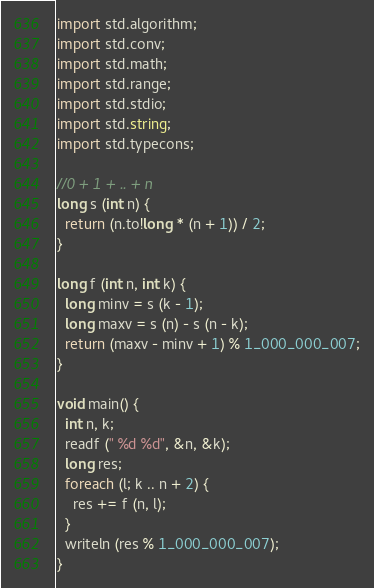Convert code to text. <code><loc_0><loc_0><loc_500><loc_500><_D_>import std.algorithm;
import std.conv;
import std.math;
import std.range;
import std.stdio;
import std.string;
import std.typecons;

//0 + 1 + .. + n
long s (int n) {
  return (n.to!long * (n + 1)) / 2; 
}

long f (int n, int k) {
  long minv = s (k - 1);
  long maxv = s (n) - s (n - k);
  return (maxv - minv + 1) % 1_000_000_007;
}

void main() {
  int n, k;
  readf (" %d %d", &n, &k);
  long res;
  foreach (l; k .. n + 2) {
    res += f (n, l);
  }
  writeln (res % 1_000_000_007);
}

</code> 